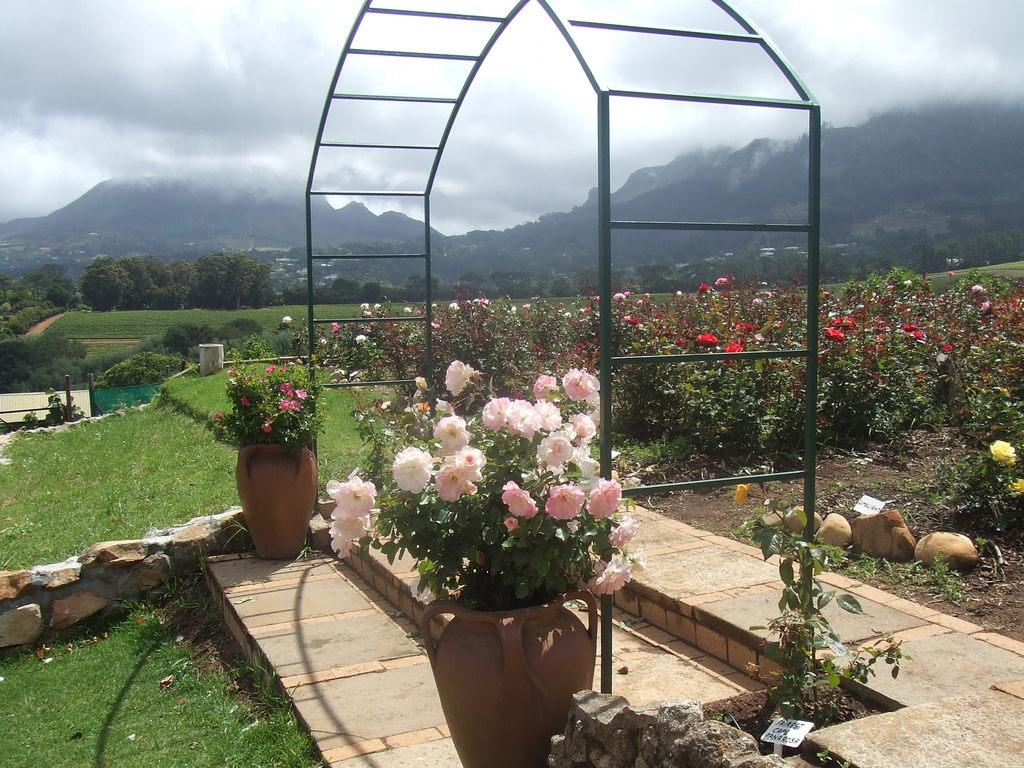What types of vegetation can be seen in the image? There are plants, flowers, and trees in the image. What are the plants in the image contained in? There are pots in the image. What architectural feature is present in the image? There is an arch in the image. What type of ground cover is visible in the image? There is grass in the image. What natural landmark is visible in the image? There is a mountain in the image. What is visible in the background of the image? The sky is visible in the background of the image. What can be seen in the sky? There are clouds in the sky. What type of watch is the mountain wearing in the image? There is no watch present in the image, as mountains are inanimate objects and cannot wear watches. 